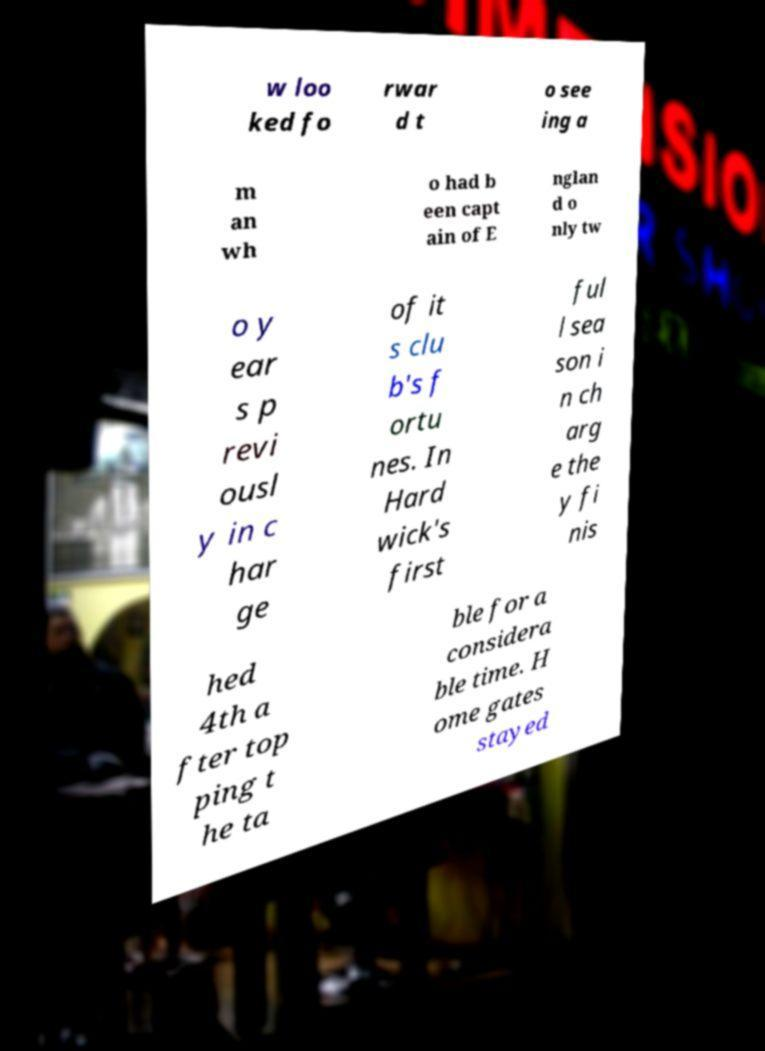For documentation purposes, I need the text within this image transcribed. Could you provide that? w loo ked fo rwar d t o see ing a m an wh o had b een capt ain of E nglan d o nly tw o y ear s p revi ousl y in c har ge of it s clu b's f ortu nes. In Hard wick's first ful l sea son i n ch arg e the y fi nis hed 4th a fter top ping t he ta ble for a considera ble time. H ome gates stayed 